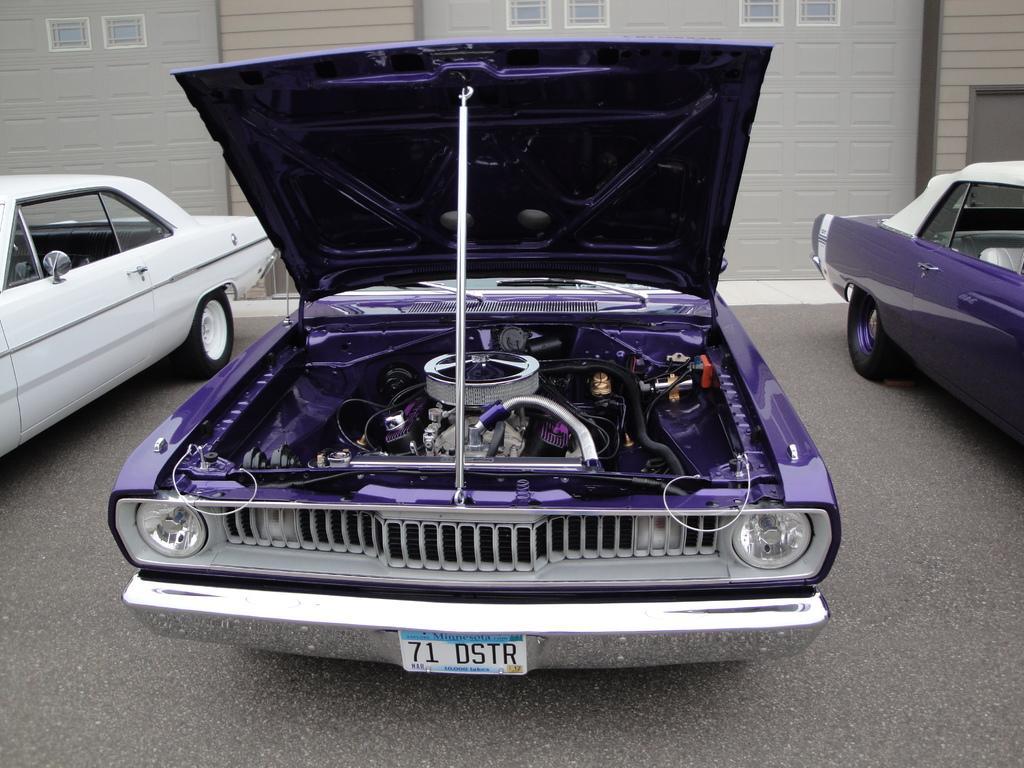In one or two sentences, can you explain what this image depicts? In this picture I can see three vehicles on the road, and in the background it looks like a building with windows. 